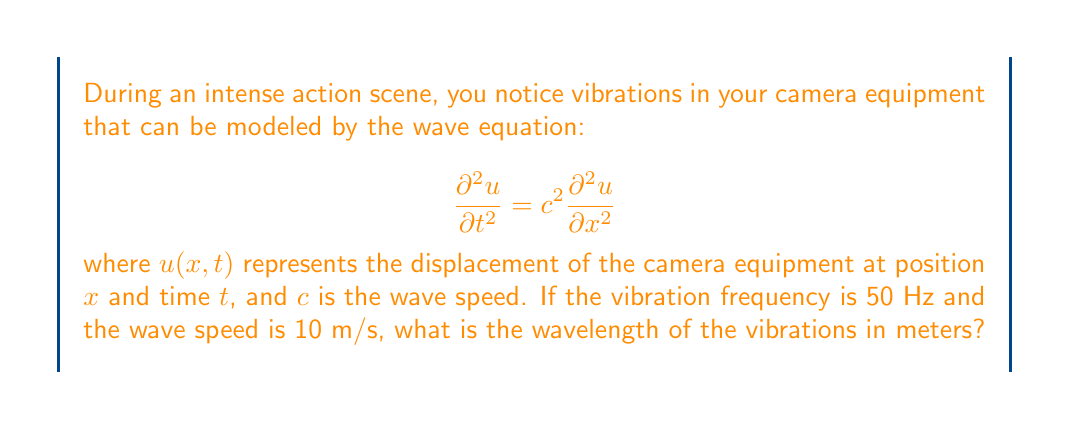Show me your answer to this math problem. To solve this problem, we'll use the relationship between frequency, wavelength, and wave speed:

1) The wave equation relates frequency $f$, wavelength $\lambda$, and wave speed $c$ as:

   $$c = f\lambda$$

2) We are given:
   - Frequency: $f = 50$ Hz
   - Wave speed: $c = 10$ m/s

3) Substituting these values into the equation:

   $$10 = 50\lambda$$

4) Solving for $\lambda$:

   $$\lambda = \frac{10}{50} = 0.2$$

Therefore, the wavelength of the vibrations is 0.2 meters.
Answer: 0.2 m 